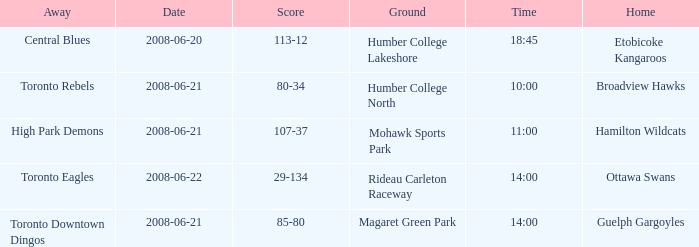What is the Away with a Ground that is humber college north? Toronto Rebels. 